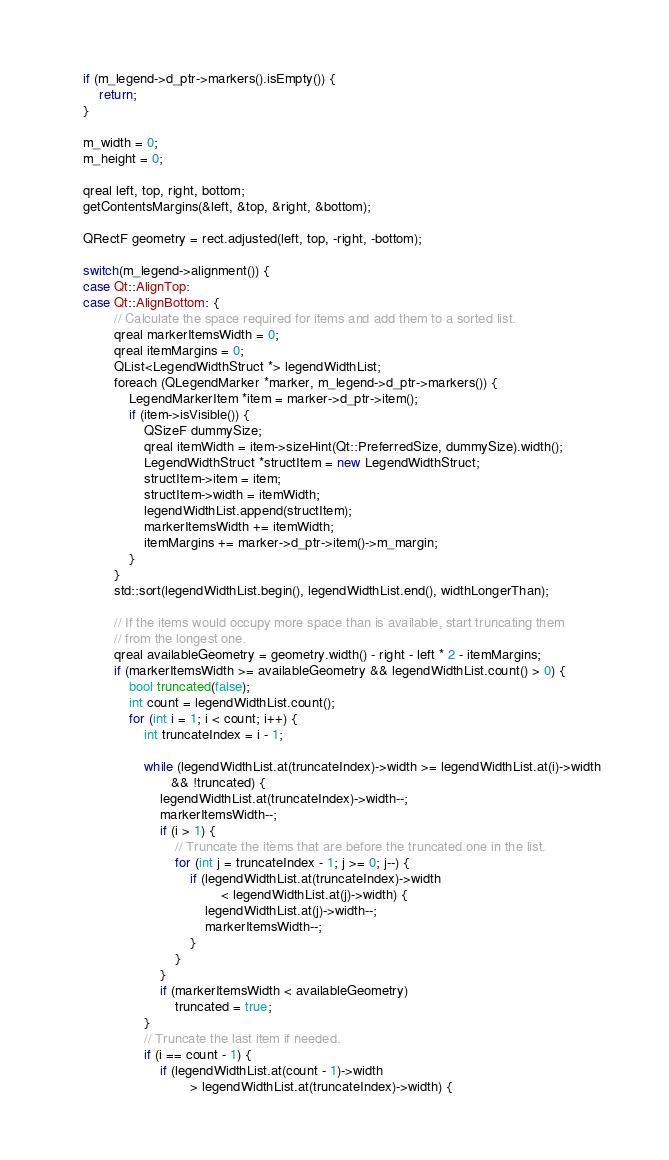<code> <loc_0><loc_0><loc_500><loc_500><_C++_>
    if (m_legend->d_ptr->markers().isEmpty()) {
        return;
    }

    m_width = 0;
    m_height = 0;

    qreal left, top, right, bottom;
    getContentsMargins(&left, &top, &right, &bottom);

    QRectF geometry = rect.adjusted(left, top, -right, -bottom);

    switch(m_legend->alignment()) {
    case Qt::AlignTop:
    case Qt::AlignBottom: {
            // Calculate the space required for items and add them to a sorted list.
            qreal markerItemsWidth = 0;
            qreal itemMargins = 0;
            QList<LegendWidthStruct *> legendWidthList;
            foreach (QLegendMarker *marker, m_legend->d_ptr->markers()) {
                LegendMarkerItem *item = marker->d_ptr->item();
                if (item->isVisible()) {
                    QSizeF dummySize;
                    qreal itemWidth = item->sizeHint(Qt::PreferredSize, dummySize).width();
                    LegendWidthStruct *structItem = new LegendWidthStruct;
                    structItem->item = item;
                    structItem->width = itemWidth;
                    legendWidthList.append(structItem);
                    markerItemsWidth += itemWidth;
                    itemMargins += marker->d_ptr->item()->m_margin;
                }
            }
            std::sort(legendWidthList.begin(), legendWidthList.end(), widthLongerThan);

            // If the items would occupy more space than is available, start truncating them
            // from the longest one.
            qreal availableGeometry = geometry.width() - right - left * 2 - itemMargins;
            if (markerItemsWidth >= availableGeometry && legendWidthList.count() > 0) {
                bool truncated(false);
                int count = legendWidthList.count();
                for (int i = 1; i < count; i++) {
                    int truncateIndex = i - 1;

                    while (legendWidthList.at(truncateIndex)->width >= legendWidthList.at(i)->width
                           && !truncated) {
                        legendWidthList.at(truncateIndex)->width--;
                        markerItemsWidth--;
                        if (i > 1) {
                            // Truncate the items that are before the truncated one in the list.
                            for (int j = truncateIndex - 1; j >= 0; j--) {
                                if (legendWidthList.at(truncateIndex)->width
                                        < legendWidthList.at(j)->width) {
                                    legendWidthList.at(j)->width--;
                                    markerItemsWidth--;
                                }
                            }
                        }
                        if (markerItemsWidth < availableGeometry)
                            truncated = true;
                    }
                    // Truncate the last item if needed.
                    if (i == count - 1) {
                        if (legendWidthList.at(count - 1)->width
                                > legendWidthList.at(truncateIndex)->width) {</code> 